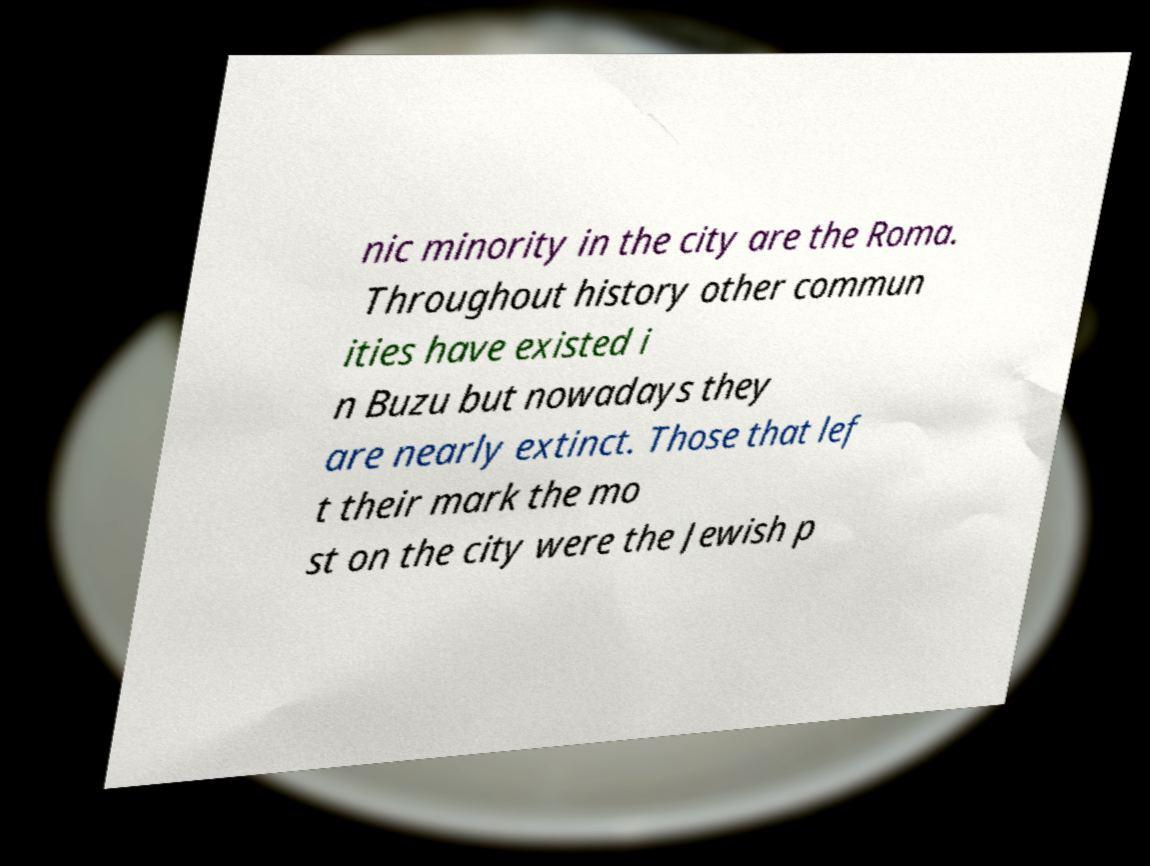There's text embedded in this image that I need extracted. Can you transcribe it verbatim? nic minority in the city are the Roma. Throughout history other commun ities have existed i n Buzu but nowadays they are nearly extinct. Those that lef t their mark the mo st on the city were the Jewish p 